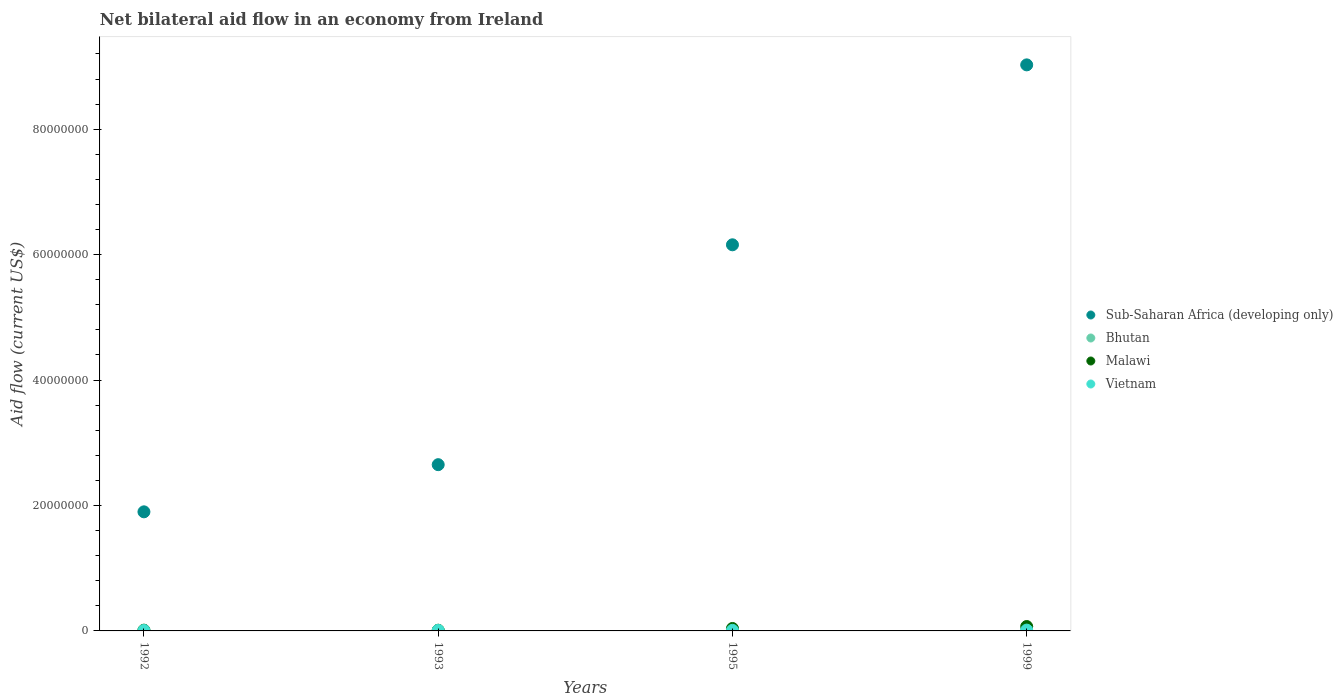How many different coloured dotlines are there?
Offer a terse response. 4. Across all years, what is the minimum net bilateral aid flow in Bhutan?
Make the answer very short. 10000. In which year was the net bilateral aid flow in Malawi minimum?
Offer a very short reply. 1993. What is the difference between the net bilateral aid flow in Bhutan in 1993 and that in 1999?
Give a very brief answer. 0. What is the average net bilateral aid flow in Bhutan per year?
Your response must be concise. 2.00e+04. In the year 1993, what is the difference between the net bilateral aid flow in Sub-Saharan Africa (developing only) and net bilateral aid flow in Bhutan?
Provide a short and direct response. 2.65e+07. What is the ratio of the net bilateral aid flow in Malawi in 1993 to that in 1995?
Give a very brief answer. 0.28. Is the net bilateral aid flow in Malawi in 1993 less than that in 1995?
Your answer should be compact. Yes. Is the difference between the net bilateral aid flow in Sub-Saharan Africa (developing only) in 1993 and 1995 greater than the difference between the net bilateral aid flow in Bhutan in 1993 and 1995?
Keep it short and to the point. No. Is it the case that in every year, the sum of the net bilateral aid flow in Bhutan and net bilateral aid flow in Sub-Saharan Africa (developing only)  is greater than the sum of net bilateral aid flow in Malawi and net bilateral aid flow in Vietnam?
Your answer should be compact. Yes. Is it the case that in every year, the sum of the net bilateral aid flow in Sub-Saharan Africa (developing only) and net bilateral aid flow in Malawi  is greater than the net bilateral aid flow in Vietnam?
Your response must be concise. Yes. Does the net bilateral aid flow in Bhutan monotonically increase over the years?
Offer a terse response. No. How many dotlines are there?
Offer a terse response. 4. Are the values on the major ticks of Y-axis written in scientific E-notation?
Provide a short and direct response. No. Does the graph contain any zero values?
Your answer should be very brief. No. How are the legend labels stacked?
Offer a very short reply. Vertical. What is the title of the graph?
Keep it short and to the point. Net bilateral aid flow in an economy from Ireland. Does "Lao PDR" appear as one of the legend labels in the graph?
Provide a succinct answer. No. What is the label or title of the X-axis?
Give a very brief answer. Years. What is the label or title of the Y-axis?
Your answer should be very brief. Aid flow (current US$). What is the Aid flow (current US$) in Sub-Saharan Africa (developing only) in 1992?
Provide a succinct answer. 1.90e+07. What is the Aid flow (current US$) in Bhutan in 1992?
Offer a terse response. 5.00e+04. What is the Aid flow (current US$) of Malawi in 1992?
Provide a succinct answer. 1.20e+05. What is the Aid flow (current US$) in Sub-Saharan Africa (developing only) in 1993?
Keep it short and to the point. 2.65e+07. What is the Aid flow (current US$) of Sub-Saharan Africa (developing only) in 1995?
Provide a succinct answer. 6.16e+07. What is the Aid flow (current US$) in Bhutan in 1995?
Keep it short and to the point. 10000. What is the Aid flow (current US$) in Malawi in 1995?
Provide a short and direct response. 3.90e+05. What is the Aid flow (current US$) in Vietnam in 1995?
Provide a succinct answer. 9.00e+04. What is the Aid flow (current US$) of Sub-Saharan Africa (developing only) in 1999?
Keep it short and to the point. 9.03e+07. What is the Aid flow (current US$) in Vietnam in 1999?
Provide a succinct answer. 1.30e+05. Across all years, what is the maximum Aid flow (current US$) in Sub-Saharan Africa (developing only)?
Make the answer very short. 9.03e+07. Across all years, what is the maximum Aid flow (current US$) of Bhutan?
Offer a terse response. 5.00e+04. Across all years, what is the minimum Aid flow (current US$) of Sub-Saharan Africa (developing only)?
Give a very brief answer. 1.90e+07. Across all years, what is the minimum Aid flow (current US$) in Bhutan?
Your response must be concise. 10000. Across all years, what is the minimum Aid flow (current US$) in Vietnam?
Make the answer very short. 7.00e+04. What is the total Aid flow (current US$) in Sub-Saharan Africa (developing only) in the graph?
Offer a terse response. 1.97e+08. What is the total Aid flow (current US$) of Malawi in the graph?
Your response must be concise. 1.32e+06. What is the total Aid flow (current US$) in Vietnam in the graph?
Make the answer very short. 3.80e+05. What is the difference between the Aid flow (current US$) of Sub-Saharan Africa (developing only) in 1992 and that in 1993?
Your answer should be very brief. -7.52e+06. What is the difference between the Aid flow (current US$) of Vietnam in 1992 and that in 1993?
Your response must be concise. -2.00e+04. What is the difference between the Aid flow (current US$) of Sub-Saharan Africa (developing only) in 1992 and that in 1995?
Your response must be concise. -4.26e+07. What is the difference between the Aid flow (current US$) of Bhutan in 1992 and that in 1995?
Keep it short and to the point. 4.00e+04. What is the difference between the Aid flow (current US$) in Malawi in 1992 and that in 1995?
Provide a succinct answer. -2.70e+05. What is the difference between the Aid flow (current US$) in Vietnam in 1992 and that in 1995?
Your response must be concise. -2.00e+04. What is the difference between the Aid flow (current US$) of Sub-Saharan Africa (developing only) in 1992 and that in 1999?
Provide a short and direct response. -7.13e+07. What is the difference between the Aid flow (current US$) of Bhutan in 1992 and that in 1999?
Keep it short and to the point. 4.00e+04. What is the difference between the Aid flow (current US$) of Malawi in 1992 and that in 1999?
Your answer should be very brief. -5.80e+05. What is the difference between the Aid flow (current US$) of Sub-Saharan Africa (developing only) in 1993 and that in 1995?
Give a very brief answer. -3.51e+07. What is the difference between the Aid flow (current US$) in Malawi in 1993 and that in 1995?
Provide a succinct answer. -2.80e+05. What is the difference between the Aid flow (current US$) of Sub-Saharan Africa (developing only) in 1993 and that in 1999?
Offer a terse response. -6.38e+07. What is the difference between the Aid flow (current US$) of Bhutan in 1993 and that in 1999?
Make the answer very short. 0. What is the difference between the Aid flow (current US$) of Malawi in 1993 and that in 1999?
Give a very brief answer. -5.90e+05. What is the difference between the Aid flow (current US$) in Sub-Saharan Africa (developing only) in 1995 and that in 1999?
Your answer should be compact. -2.87e+07. What is the difference between the Aid flow (current US$) of Bhutan in 1995 and that in 1999?
Ensure brevity in your answer.  0. What is the difference between the Aid flow (current US$) in Malawi in 1995 and that in 1999?
Give a very brief answer. -3.10e+05. What is the difference between the Aid flow (current US$) in Vietnam in 1995 and that in 1999?
Make the answer very short. -4.00e+04. What is the difference between the Aid flow (current US$) in Sub-Saharan Africa (developing only) in 1992 and the Aid flow (current US$) in Bhutan in 1993?
Keep it short and to the point. 1.90e+07. What is the difference between the Aid flow (current US$) in Sub-Saharan Africa (developing only) in 1992 and the Aid flow (current US$) in Malawi in 1993?
Your answer should be very brief. 1.89e+07. What is the difference between the Aid flow (current US$) of Sub-Saharan Africa (developing only) in 1992 and the Aid flow (current US$) of Vietnam in 1993?
Ensure brevity in your answer.  1.89e+07. What is the difference between the Aid flow (current US$) of Bhutan in 1992 and the Aid flow (current US$) of Malawi in 1993?
Provide a succinct answer. -6.00e+04. What is the difference between the Aid flow (current US$) of Bhutan in 1992 and the Aid flow (current US$) of Vietnam in 1993?
Your answer should be compact. -4.00e+04. What is the difference between the Aid flow (current US$) of Sub-Saharan Africa (developing only) in 1992 and the Aid flow (current US$) of Bhutan in 1995?
Ensure brevity in your answer.  1.90e+07. What is the difference between the Aid flow (current US$) of Sub-Saharan Africa (developing only) in 1992 and the Aid flow (current US$) of Malawi in 1995?
Ensure brevity in your answer.  1.86e+07. What is the difference between the Aid flow (current US$) of Sub-Saharan Africa (developing only) in 1992 and the Aid flow (current US$) of Vietnam in 1995?
Give a very brief answer. 1.89e+07. What is the difference between the Aid flow (current US$) of Bhutan in 1992 and the Aid flow (current US$) of Vietnam in 1995?
Offer a very short reply. -4.00e+04. What is the difference between the Aid flow (current US$) of Malawi in 1992 and the Aid flow (current US$) of Vietnam in 1995?
Give a very brief answer. 3.00e+04. What is the difference between the Aid flow (current US$) in Sub-Saharan Africa (developing only) in 1992 and the Aid flow (current US$) in Bhutan in 1999?
Give a very brief answer. 1.90e+07. What is the difference between the Aid flow (current US$) of Sub-Saharan Africa (developing only) in 1992 and the Aid flow (current US$) of Malawi in 1999?
Give a very brief answer. 1.83e+07. What is the difference between the Aid flow (current US$) of Sub-Saharan Africa (developing only) in 1992 and the Aid flow (current US$) of Vietnam in 1999?
Offer a very short reply. 1.89e+07. What is the difference between the Aid flow (current US$) in Bhutan in 1992 and the Aid flow (current US$) in Malawi in 1999?
Keep it short and to the point. -6.50e+05. What is the difference between the Aid flow (current US$) in Sub-Saharan Africa (developing only) in 1993 and the Aid flow (current US$) in Bhutan in 1995?
Make the answer very short. 2.65e+07. What is the difference between the Aid flow (current US$) in Sub-Saharan Africa (developing only) in 1993 and the Aid flow (current US$) in Malawi in 1995?
Ensure brevity in your answer.  2.61e+07. What is the difference between the Aid flow (current US$) of Sub-Saharan Africa (developing only) in 1993 and the Aid flow (current US$) of Vietnam in 1995?
Give a very brief answer. 2.64e+07. What is the difference between the Aid flow (current US$) in Bhutan in 1993 and the Aid flow (current US$) in Malawi in 1995?
Your response must be concise. -3.80e+05. What is the difference between the Aid flow (current US$) in Bhutan in 1993 and the Aid flow (current US$) in Vietnam in 1995?
Your answer should be very brief. -8.00e+04. What is the difference between the Aid flow (current US$) in Sub-Saharan Africa (developing only) in 1993 and the Aid flow (current US$) in Bhutan in 1999?
Provide a short and direct response. 2.65e+07. What is the difference between the Aid flow (current US$) in Sub-Saharan Africa (developing only) in 1993 and the Aid flow (current US$) in Malawi in 1999?
Offer a terse response. 2.58e+07. What is the difference between the Aid flow (current US$) in Sub-Saharan Africa (developing only) in 1993 and the Aid flow (current US$) in Vietnam in 1999?
Provide a succinct answer. 2.64e+07. What is the difference between the Aid flow (current US$) of Bhutan in 1993 and the Aid flow (current US$) of Malawi in 1999?
Make the answer very short. -6.90e+05. What is the difference between the Aid flow (current US$) of Bhutan in 1993 and the Aid flow (current US$) of Vietnam in 1999?
Your response must be concise. -1.20e+05. What is the difference between the Aid flow (current US$) of Sub-Saharan Africa (developing only) in 1995 and the Aid flow (current US$) of Bhutan in 1999?
Keep it short and to the point. 6.16e+07. What is the difference between the Aid flow (current US$) of Sub-Saharan Africa (developing only) in 1995 and the Aid flow (current US$) of Malawi in 1999?
Ensure brevity in your answer.  6.09e+07. What is the difference between the Aid flow (current US$) in Sub-Saharan Africa (developing only) in 1995 and the Aid flow (current US$) in Vietnam in 1999?
Ensure brevity in your answer.  6.14e+07. What is the difference between the Aid flow (current US$) of Bhutan in 1995 and the Aid flow (current US$) of Malawi in 1999?
Make the answer very short. -6.90e+05. What is the average Aid flow (current US$) in Sub-Saharan Africa (developing only) per year?
Ensure brevity in your answer.  4.93e+07. What is the average Aid flow (current US$) in Bhutan per year?
Your answer should be compact. 2.00e+04. What is the average Aid flow (current US$) in Vietnam per year?
Give a very brief answer. 9.50e+04. In the year 1992, what is the difference between the Aid flow (current US$) in Sub-Saharan Africa (developing only) and Aid flow (current US$) in Bhutan?
Give a very brief answer. 1.89e+07. In the year 1992, what is the difference between the Aid flow (current US$) in Sub-Saharan Africa (developing only) and Aid flow (current US$) in Malawi?
Keep it short and to the point. 1.89e+07. In the year 1992, what is the difference between the Aid flow (current US$) in Sub-Saharan Africa (developing only) and Aid flow (current US$) in Vietnam?
Provide a short and direct response. 1.89e+07. In the year 1992, what is the difference between the Aid flow (current US$) in Bhutan and Aid flow (current US$) in Vietnam?
Offer a very short reply. -2.00e+04. In the year 1993, what is the difference between the Aid flow (current US$) in Sub-Saharan Africa (developing only) and Aid flow (current US$) in Bhutan?
Provide a short and direct response. 2.65e+07. In the year 1993, what is the difference between the Aid flow (current US$) of Sub-Saharan Africa (developing only) and Aid flow (current US$) of Malawi?
Offer a very short reply. 2.64e+07. In the year 1993, what is the difference between the Aid flow (current US$) in Sub-Saharan Africa (developing only) and Aid flow (current US$) in Vietnam?
Your answer should be compact. 2.64e+07. In the year 1993, what is the difference between the Aid flow (current US$) in Bhutan and Aid flow (current US$) in Malawi?
Keep it short and to the point. -1.00e+05. In the year 1993, what is the difference between the Aid flow (current US$) of Bhutan and Aid flow (current US$) of Vietnam?
Offer a terse response. -8.00e+04. In the year 1993, what is the difference between the Aid flow (current US$) in Malawi and Aid flow (current US$) in Vietnam?
Your response must be concise. 2.00e+04. In the year 1995, what is the difference between the Aid flow (current US$) of Sub-Saharan Africa (developing only) and Aid flow (current US$) of Bhutan?
Keep it short and to the point. 6.16e+07. In the year 1995, what is the difference between the Aid flow (current US$) in Sub-Saharan Africa (developing only) and Aid flow (current US$) in Malawi?
Your answer should be compact. 6.12e+07. In the year 1995, what is the difference between the Aid flow (current US$) of Sub-Saharan Africa (developing only) and Aid flow (current US$) of Vietnam?
Give a very brief answer. 6.15e+07. In the year 1995, what is the difference between the Aid flow (current US$) of Bhutan and Aid flow (current US$) of Malawi?
Give a very brief answer. -3.80e+05. In the year 1995, what is the difference between the Aid flow (current US$) of Bhutan and Aid flow (current US$) of Vietnam?
Provide a short and direct response. -8.00e+04. In the year 1999, what is the difference between the Aid flow (current US$) of Sub-Saharan Africa (developing only) and Aid flow (current US$) of Bhutan?
Your response must be concise. 9.02e+07. In the year 1999, what is the difference between the Aid flow (current US$) in Sub-Saharan Africa (developing only) and Aid flow (current US$) in Malawi?
Provide a short and direct response. 8.96e+07. In the year 1999, what is the difference between the Aid flow (current US$) in Sub-Saharan Africa (developing only) and Aid flow (current US$) in Vietnam?
Your answer should be compact. 9.01e+07. In the year 1999, what is the difference between the Aid flow (current US$) of Bhutan and Aid flow (current US$) of Malawi?
Offer a terse response. -6.90e+05. In the year 1999, what is the difference between the Aid flow (current US$) of Malawi and Aid flow (current US$) of Vietnam?
Offer a very short reply. 5.70e+05. What is the ratio of the Aid flow (current US$) of Sub-Saharan Africa (developing only) in 1992 to that in 1993?
Provide a succinct answer. 0.72. What is the ratio of the Aid flow (current US$) in Vietnam in 1992 to that in 1993?
Offer a very short reply. 0.78. What is the ratio of the Aid flow (current US$) in Sub-Saharan Africa (developing only) in 1992 to that in 1995?
Your answer should be very brief. 0.31. What is the ratio of the Aid flow (current US$) of Malawi in 1992 to that in 1995?
Give a very brief answer. 0.31. What is the ratio of the Aid flow (current US$) in Vietnam in 1992 to that in 1995?
Your answer should be compact. 0.78. What is the ratio of the Aid flow (current US$) of Sub-Saharan Africa (developing only) in 1992 to that in 1999?
Provide a succinct answer. 0.21. What is the ratio of the Aid flow (current US$) of Bhutan in 1992 to that in 1999?
Make the answer very short. 5. What is the ratio of the Aid flow (current US$) in Malawi in 1992 to that in 1999?
Provide a short and direct response. 0.17. What is the ratio of the Aid flow (current US$) in Vietnam in 1992 to that in 1999?
Your answer should be compact. 0.54. What is the ratio of the Aid flow (current US$) in Sub-Saharan Africa (developing only) in 1993 to that in 1995?
Offer a very short reply. 0.43. What is the ratio of the Aid flow (current US$) of Malawi in 1993 to that in 1995?
Offer a very short reply. 0.28. What is the ratio of the Aid flow (current US$) of Vietnam in 1993 to that in 1995?
Offer a very short reply. 1. What is the ratio of the Aid flow (current US$) of Sub-Saharan Africa (developing only) in 1993 to that in 1999?
Give a very brief answer. 0.29. What is the ratio of the Aid flow (current US$) in Bhutan in 1993 to that in 1999?
Your answer should be very brief. 1. What is the ratio of the Aid flow (current US$) of Malawi in 1993 to that in 1999?
Ensure brevity in your answer.  0.16. What is the ratio of the Aid flow (current US$) of Vietnam in 1993 to that in 1999?
Offer a very short reply. 0.69. What is the ratio of the Aid flow (current US$) in Sub-Saharan Africa (developing only) in 1995 to that in 1999?
Offer a very short reply. 0.68. What is the ratio of the Aid flow (current US$) of Bhutan in 1995 to that in 1999?
Keep it short and to the point. 1. What is the ratio of the Aid flow (current US$) in Malawi in 1995 to that in 1999?
Keep it short and to the point. 0.56. What is the ratio of the Aid flow (current US$) of Vietnam in 1995 to that in 1999?
Offer a terse response. 0.69. What is the difference between the highest and the second highest Aid flow (current US$) of Sub-Saharan Africa (developing only)?
Provide a succinct answer. 2.87e+07. What is the difference between the highest and the second highest Aid flow (current US$) of Bhutan?
Ensure brevity in your answer.  4.00e+04. What is the difference between the highest and the second highest Aid flow (current US$) in Malawi?
Make the answer very short. 3.10e+05. What is the difference between the highest and the lowest Aid flow (current US$) in Sub-Saharan Africa (developing only)?
Your answer should be compact. 7.13e+07. What is the difference between the highest and the lowest Aid flow (current US$) of Malawi?
Offer a very short reply. 5.90e+05. 